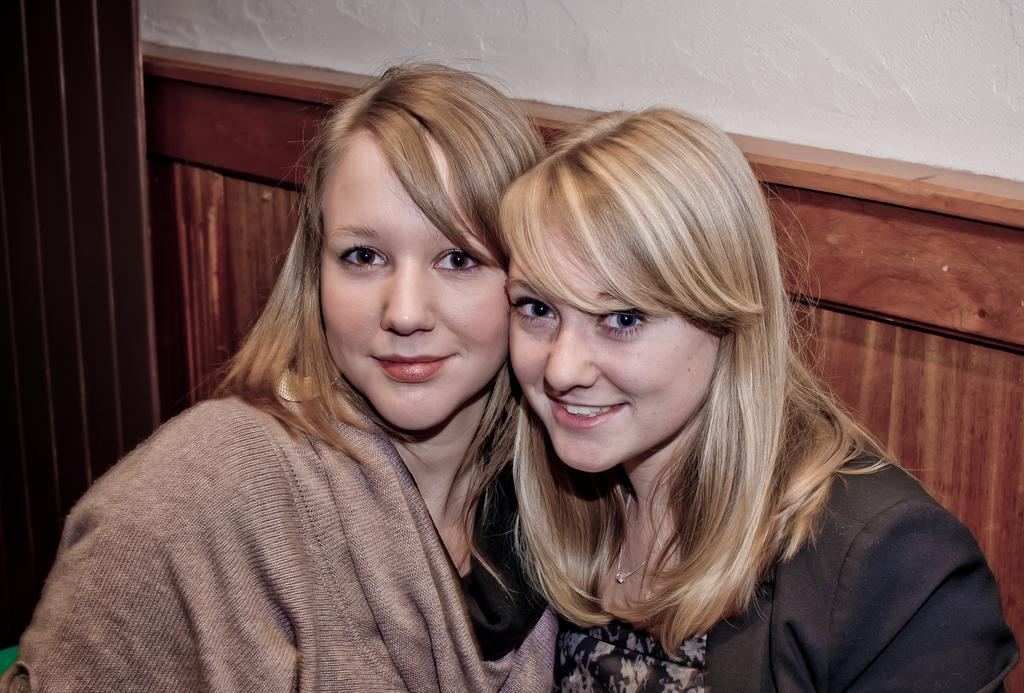Who are the main subjects in the image? There are two ladies in the center of the image. What is the ladies' facial expression? The ladies are smiling. What can be seen in the background of the image? There is a wall in the background of the image. How many bikes are parked next to the ladies in the image? There are no bikes present in the image. What type of rose can be seen in the ladies' hands in the image? There are no roses present in the image. 